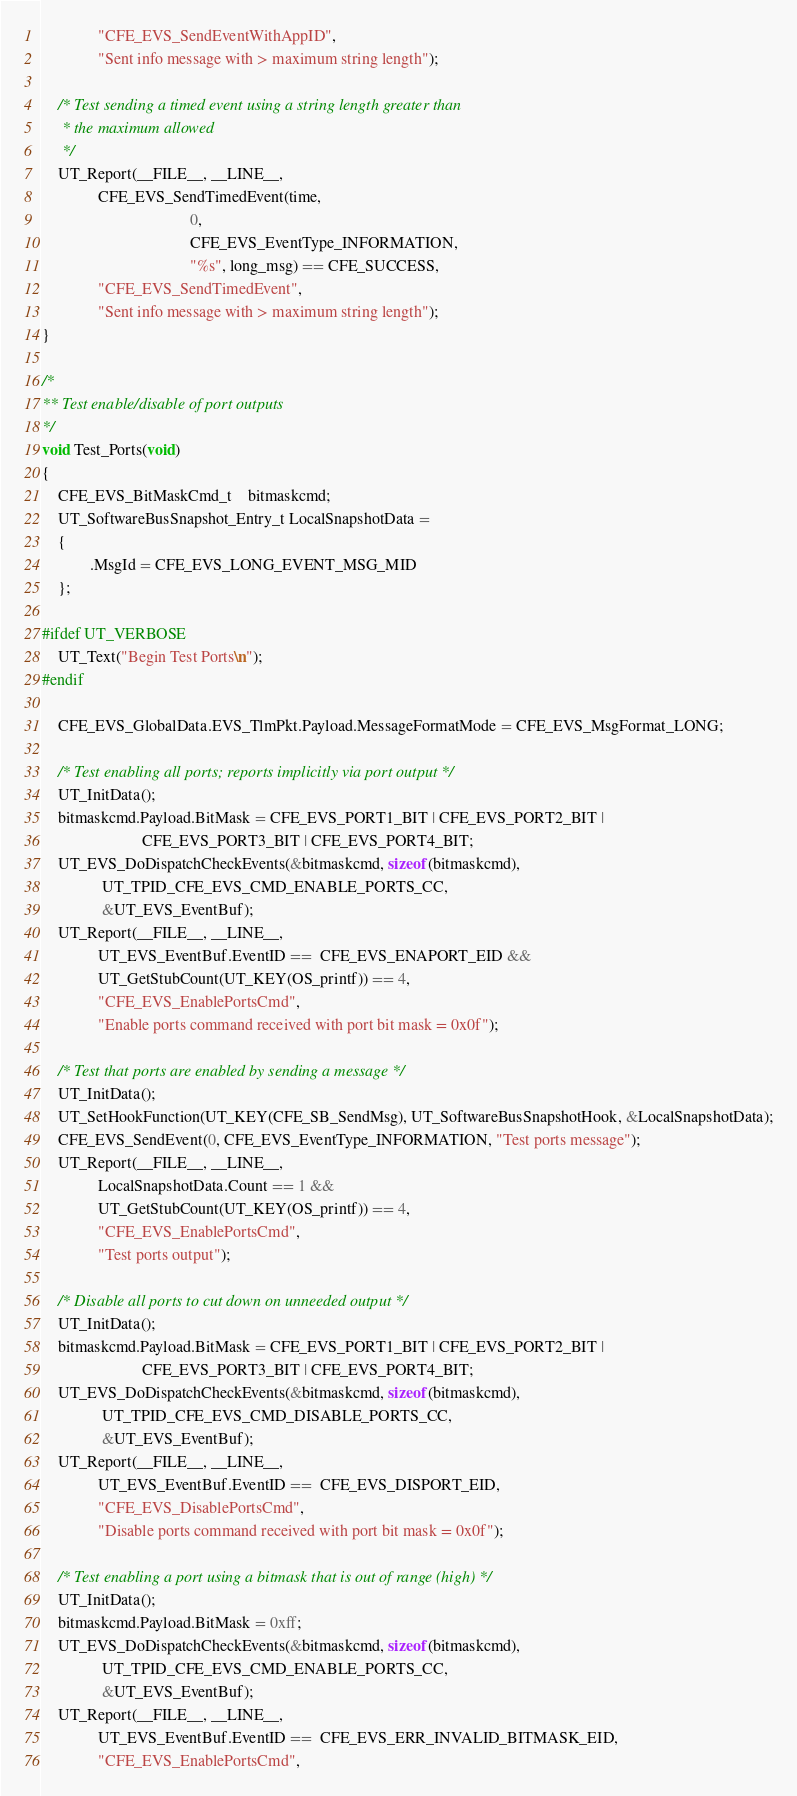Convert code to text. <code><loc_0><loc_0><loc_500><loc_500><_C_>              "CFE_EVS_SendEventWithAppID",
              "Sent info message with > maximum string length");

    /* Test sending a timed event using a string length greater than
     * the maximum allowed
     */
    UT_Report(__FILE__, __LINE__,
              CFE_EVS_SendTimedEvent(time,
                                     0,
                                     CFE_EVS_EventType_INFORMATION,
                                     "%s", long_msg) == CFE_SUCCESS,
              "CFE_EVS_SendTimedEvent",
              "Sent info message with > maximum string length");
}

/*
** Test enable/disable of port outputs
*/
void Test_Ports(void)
{
    CFE_EVS_BitMaskCmd_t    bitmaskcmd;
    UT_SoftwareBusSnapshot_Entry_t LocalSnapshotData =
    {
            .MsgId = CFE_EVS_LONG_EVENT_MSG_MID
    };

#ifdef UT_VERBOSE
    UT_Text("Begin Test Ports\n");
#endif

    CFE_EVS_GlobalData.EVS_TlmPkt.Payload.MessageFormatMode = CFE_EVS_MsgFormat_LONG;

    /* Test enabling all ports; reports implicitly via port output */
    UT_InitData();
    bitmaskcmd.Payload.BitMask = CFE_EVS_PORT1_BIT | CFE_EVS_PORT2_BIT |
                         CFE_EVS_PORT3_BIT | CFE_EVS_PORT4_BIT;
    UT_EVS_DoDispatchCheckEvents(&bitmaskcmd, sizeof(bitmaskcmd),
               UT_TPID_CFE_EVS_CMD_ENABLE_PORTS_CC,
               &UT_EVS_EventBuf);
    UT_Report(__FILE__, __LINE__,
              UT_EVS_EventBuf.EventID ==  CFE_EVS_ENAPORT_EID &&
              UT_GetStubCount(UT_KEY(OS_printf)) == 4,
              "CFE_EVS_EnablePortsCmd",
              "Enable ports command received with port bit mask = 0x0f");

    /* Test that ports are enabled by sending a message */
    UT_InitData();
    UT_SetHookFunction(UT_KEY(CFE_SB_SendMsg), UT_SoftwareBusSnapshotHook, &LocalSnapshotData);
    CFE_EVS_SendEvent(0, CFE_EVS_EventType_INFORMATION, "Test ports message");
    UT_Report(__FILE__, __LINE__,
              LocalSnapshotData.Count == 1 &&
              UT_GetStubCount(UT_KEY(OS_printf)) == 4,
              "CFE_EVS_EnablePortsCmd",
              "Test ports output");

    /* Disable all ports to cut down on unneeded output */
    UT_InitData();
    bitmaskcmd.Payload.BitMask = CFE_EVS_PORT1_BIT | CFE_EVS_PORT2_BIT |
                         CFE_EVS_PORT3_BIT | CFE_EVS_PORT4_BIT;
    UT_EVS_DoDispatchCheckEvents(&bitmaskcmd, sizeof(bitmaskcmd),
               UT_TPID_CFE_EVS_CMD_DISABLE_PORTS_CC,
               &UT_EVS_EventBuf);
    UT_Report(__FILE__, __LINE__,
              UT_EVS_EventBuf.EventID ==  CFE_EVS_DISPORT_EID,
              "CFE_EVS_DisablePortsCmd",
              "Disable ports command received with port bit mask = 0x0f");

    /* Test enabling a port using a bitmask that is out of range (high) */
    UT_InitData();
    bitmaskcmd.Payload.BitMask = 0xff;
    UT_EVS_DoDispatchCheckEvents(&bitmaskcmd, sizeof(bitmaskcmd),
               UT_TPID_CFE_EVS_CMD_ENABLE_PORTS_CC,
               &UT_EVS_EventBuf);
    UT_Report(__FILE__, __LINE__,
              UT_EVS_EventBuf.EventID ==  CFE_EVS_ERR_INVALID_BITMASK_EID,
              "CFE_EVS_EnablePortsCmd",</code> 